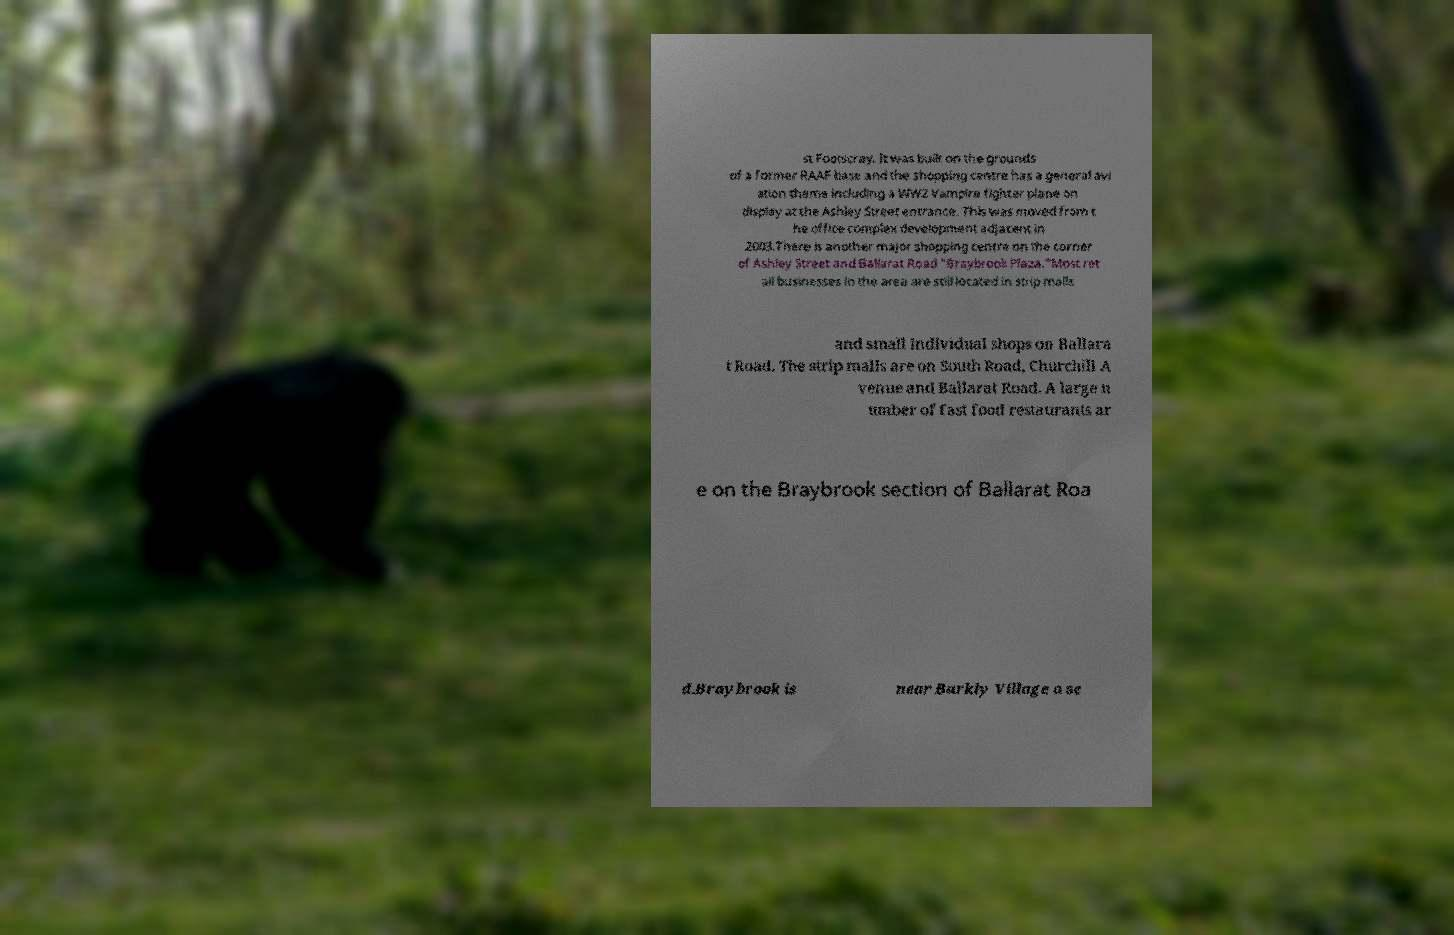I need the written content from this picture converted into text. Can you do that? st Footscray. It was built on the grounds of a former RAAF base and the shopping centre has a general avi ation theme including a WW2 Vampire fighter plane on display at the Ashley Street entrance. This was moved from t he office complex development adjacent in 2003.There is another major shopping centre on the corner of Ashley Street and Ballarat Road "Braybrook Plaza."Most ret ail businesses in the area are still located in strip malls and small individual shops on Ballara t Road. The strip malls are on South Road, Churchill A venue and Ballarat Road. A large n umber of fast food restaurants ar e on the Braybrook section of Ballarat Roa d.Braybrook is near Barkly Village a se 